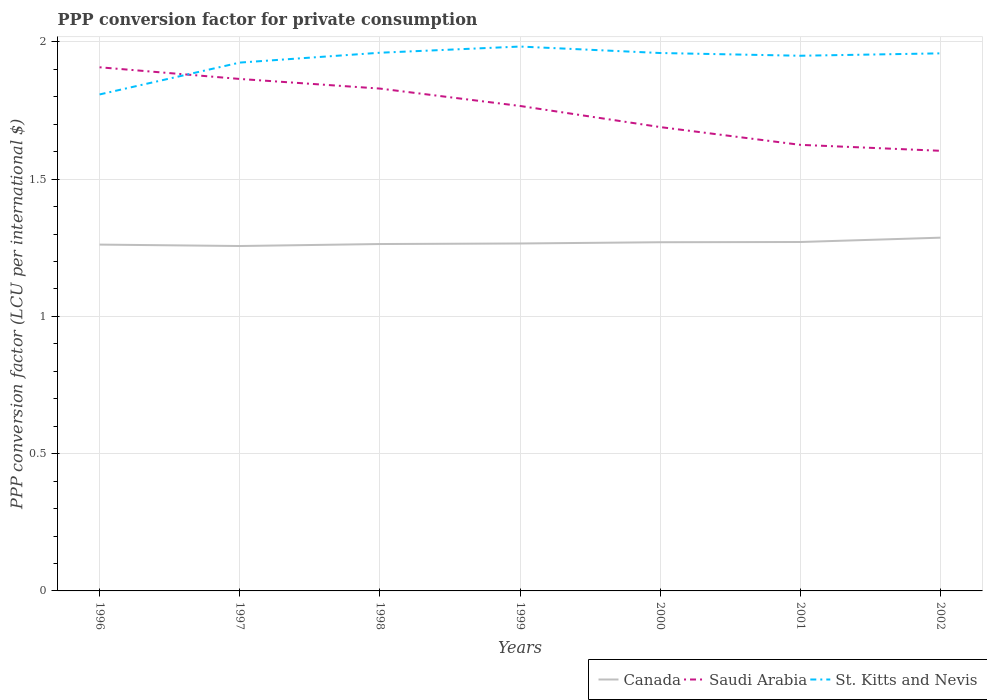How many different coloured lines are there?
Your response must be concise. 3. Does the line corresponding to St. Kitts and Nevis intersect with the line corresponding to Canada?
Keep it short and to the point. No. Across all years, what is the maximum PPP conversion factor for private consumption in Canada?
Your response must be concise. 1.26. What is the total PPP conversion factor for private consumption in Saudi Arabia in the graph?
Provide a succinct answer. 0.3. What is the difference between the highest and the second highest PPP conversion factor for private consumption in St. Kitts and Nevis?
Keep it short and to the point. 0.17. What is the difference between the highest and the lowest PPP conversion factor for private consumption in Saudi Arabia?
Keep it short and to the point. 4. Is the PPP conversion factor for private consumption in St. Kitts and Nevis strictly greater than the PPP conversion factor for private consumption in Saudi Arabia over the years?
Offer a very short reply. No. What is the difference between two consecutive major ticks on the Y-axis?
Your answer should be compact. 0.5. Does the graph contain any zero values?
Offer a very short reply. No. What is the title of the graph?
Keep it short and to the point. PPP conversion factor for private consumption. Does "Korea (Democratic)" appear as one of the legend labels in the graph?
Offer a very short reply. No. What is the label or title of the X-axis?
Provide a succinct answer. Years. What is the label or title of the Y-axis?
Give a very brief answer. PPP conversion factor (LCU per international $). What is the PPP conversion factor (LCU per international $) of Canada in 1996?
Your response must be concise. 1.26. What is the PPP conversion factor (LCU per international $) of Saudi Arabia in 1996?
Your answer should be compact. 1.91. What is the PPP conversion factor (LCU per international $) in St. Kitts and Nevis in 1996?
Provide a succinct answer. 1.81. What is the PPP conversion factor (LCU per international $) of Canada in 1997?
Keep it short and to the point. 1.26. What is the PPP conversion factor (LCU per international $) in Saudi Arabia in 1997?
Your response must be concise. 1.87. What is the PPP conversion factor (LCU per international $) in St. Kitts and Nevis in 1997?
Keep it short and to the point. 1.92. What is the PPP conversion factor (LCU per international $) of Canada in 1998?
Offer a terse response. 1.26. What is the PPP conversion factor (LCU per international $) in Saudi Arabia in 1998?
Your answer should be very brief. 1.83. What is the PPP conversion factor (LCU per international $) in St. Kitts and Nevis in 1998?
Ensure brevity in your answer.  1.96. What is the PPP conversion factor (LCU per international $) in Canada in 1999?
Make the answer very short. 1.27. What is the PPP conversion factor (LCU per international $) of Saudi Arabia in 1999?
Provide a succinct answer. 1.77. What is the PPP conversion factor (LCU per international $) of St. Kitts and Nevis in 1999?
Your answer should be compact. 1.98. What is the PPP conversion factor (LCU per international $) of Canada in 2000?
Offer a terse response. 1.27. What is the PPP conversion factor (LCU per international $) in Saudi Arabia in 2000?
Make the answer very short. 1.69. What is the PPP conversion factor (LCU per international $) of St. Kitts and Nevis in 2000?
Offer a very short reply. 1.96. What is the PPP conversion factor (LCU per international $) in Canada in 2001?
Provide a succinct answer. 1.27. What is the PPP conversion factor (LCU per international $) in Saudi Arabia in 2001?
Keep it short and to the point. 1.63. What is the PPP conversion factor (LCU per international $) of St. Kitts and Nevis in 2001?
Offer a very short reply. 1.95. What is the PPP conversion factor (LCU per international $) in Canada in 2002?
Provide a succinct answer. 1.29. What is the PPP conversion factor (LCU per international $) in Saudi Arabia in 2002?
Provide a short and direct response. 1.6. What is the PPP conversion factor (LCU per international $) of St. Kitts and Nevis in 2002?
Keep it short and to the point. 1.96. Across all years, what is the maximum PPP conversion factor (LCU per international $) of Canada?
Give a very brief answer. 1.29. Across all years, what is the maximum PPP conversion factor (LCU per international $) of Saudi Arabia?
Offer a very short reply. 1.91. Across all years, what is the maximum PPP conversion factor (LCU per international $) of St. Kitts and Nevis?
Ensure brevity in your answer.  1.98. Across all years, what is the minimum PPP conversion factor (LCU per international $) in Canada?
Offer a terse response. 1.26. Across all years, what is the minimum PPP conversion factor (LCU per international $) in Saudi Arabia?
Provide a succinct answer. 1.6. Across all years, what is the minimum PPP conversion factor (LCU per international $) of St. Kitts and Nevis?
Give a very brief answer. 1.81. What is the total PPP conversion factor (LCU per international $) in Canada in the graph?
Provide a short and direct response. 8.88. What is the total PPP conversion factor (LCU per international $) of Saudi Arabia in the graph?
Provide a succinct answer. 12.29. What is the total PPP conversion factor (LCU per international $) in St. Kitts and Nevis in the graph?
Offer a terse response. 13.55. What is the difference between the PPP conversion factor (LCU per international $) in Canada in 1996 and that in 1997?
Offer a very short reply. 0.01. What is the difference between the PPP conversion factor (LCU per international $) in Saudi Arabia in 1996 and that in 1997?
Your answer should be compact. 0.04. What is the difference between the PPP conversion factor (LCU per international $) in St. Kitts and Nevis in 1996 and that in 1997?
Offer a terse response. -0.12. What is the difference between the PPP conversion factor (LCU per international $) in Canada in 1996 and that in 1998?
Provide a succinct answer. -0. What is the difference between the PPP conversion factor (LCU per international $) of Saudi Arabia in 1996 and that in 1998?
Keep it short and to the point. 0.08. What is the difference between the PPP conversion factor (LCU per international $) in St. Kitts and Nevis in 1996 and that in 1998?
Give a very brief answer. -0.15. What is the difference between the PPP conversion factor (LCU per international $) in Canada in 1996 and that in 1999?
Offer a very short reply. -0. What is the difference between the PPP conversion factor (LCU per international $) of Saudi Arabia in 1996 and that in 1999?
Provide a short and direct response. 0.14. What is the difference between the PPP conversion factor (LCU per international $) in St. Kitts and Nevis in 1996 and that in 1999?
Give a very brief answer. -0.17. What is the difference between the PPP conversion factor (LCU per international $) in Canada in 1996 and that in 2000?
Your answer should be compact. -0.01. What is the difference between the PPP conversion factor (LCU per international $) of Saudi Arabia in 1996 and that in 2000?
Make the answer very short. 0.22. What is the difference between the PPP conversion factor (LCU per international $) of St. Kitts and Nevis in 1996 and that in 2000?
Make the answer very short. -0.15. What is the difference between the PPP conversion factor (LCU per international $) in Canada in 1996 and that in 2001?
Provide a succinct answer. -0.01. What is the difference between the PPP conversion factor (LCU per international $) in Saudi Arabia in 1996 and that in 2001?
Offer a very short reply. 0.28. What is the difference between the PPP conversion factor (LCU per international $) in St. Kitts and Nevis in 1996 and that in 2001?
Give a very brief answer. -0.14. What is the difference between the PPP conversion factor (LCU per international $) of Canada in 1996 and that in 2002?
Your answer should be compact. -0.03. What is the difference between the PPP conversion factor (LCU per international $) of Saudi Arabia in 1996 and that in 2002?
Your response must be concise. 0.3. What is the difference between the PPP conversion factor (LCU per international $) in St. Kitts and Nevis in 1996 and that in 2002?
Make the answer very short. -0.15. What is the difference between the PPP conversion factor (LCU per international $) of Canada in 1997 and that in 1998?
Provide a succinct answer. -0.01. What is the difference between the PPP conversion factor (LCU per international $) of Saudi Arabia in 1997 and that in 1998?
Ensure brevity in your answer.  0.04. What is the difference between the PPP conversion factor (LCU per international $) in St. Kitts and Nevis in 1997 and that in 1998?
Your answer should be compact. -0.04. What is the difference between the PPP conversion factor (LCU per international $) of Canada in 1997 and that in 1999?
Ensure brevity in your answer.  -0.01. What is the difference between the PPP conversion factor (LCU per international $) of Saudi Arabia in 1997 and that in 1999?
Make the answer very short. 0.1. What is the difference between the PPP conversion factor (LCU per international $) in St. Kitts and Nevis in 1997 and that in 1999?
Your answer should be compact. -0.06. What is the difference between the PPP conversion factor (LCU per international $) in Canada in 1997 and that in 2000?
Make the answer very short. -0.01. What is the difference between the PPP conversion factor (LCU per international $) in Saudi Arabia in 1997 and that in 2000?
Make the answer very short. 0.18. What is the difference between the PPP conversion factor (LCU per international $) in St. Kitts and Nevis in 1997 and that in 2000?
Keep it short and to the point. -0.03. What is the difference between the PPP conversion factor (LCU per international $) of Canada in 1997 and that in 2001?
Keep it short and to the point. -0.01. What is the difference between the PPP conversion factor (LCU per international $) of Saudi Arabia in 1997 and that in 2001?
Make the answer very short. 0.24. What is the difference between the PPP conversion factor (LCU per international $) in St. Kitts and Nevis in 1997 and that in 2001?
Your answer should be very brief. -0.02. What is the difference between the PPP conversion factor (LCU per international $) of Canada in 1997 and that in 2002?
Your response must be concise. -0.03. What is the difference between the PPP conversion factor (LCU per international $) in Saudi Arabia in 1997 and that in 2002?
Give a very brief answer. 0.26. What is the difference between the PPP conversion factor (LCU per international $) in St. Kitts and Nevis in 1997 and that in 2002?
Your response must be concise. -0.03. What is the difference between the PPP conversion factor (LCU per international $) of Canada in 1998 and that in 1999?
Provide a short and direct response. -0. What is the difference between the PPP conversion factor (LCU per international $) of Saudi Arabia in 1998 and that in 1999?
Provide a short and direct response. 0.06. What is the difference between the PPP conversion factor (LCU per international $) in St. Kitts and Nevis in 1998 and that in 1999?
Your response must be concise. -0.02. What is the difference between the PPP conversion factor (LCU per international $) of Canada in 1998 and that in 2000?
Offer a terse response. -0.01. What is the difference between the PPP conversion factor (LCU per international $) in Saudi Arabia in 1998 and that in 2000?
Keep it short and to the point. 0.14. What is the difference between the PPP conversion factor (LCU per international $) of St. Kitts and Nevis in 1998 and that in 2000?
Provide a short and direct response. 0. What is the difference between the PPP conversion factor (LCU per international $) in Canada in 1998 and that in 2001?
Offer a very short reply. -0.01. What is the difference between the PPP conversion factor (LCU per international $) in Saudi Arabia in 1998 and that in 2001?
Give a very brief answer. 0.2. What is the difference between the PPP conversion factor (LCU per international $) of St. Kitts and Nevis in 1998 and that in 2001?
Give a very brief answer. 0.01. What is the difference between the PPP conversion factor (LCU per international $) of Canada in 1998 and that in 2002?
Make the answer very short. -0.02. What is the difference between the PPP conversion factor (LCU per international $) in Saudi Arabia in 1998 and that in 2002?
Provide a short and direct response. 0.23. What is the difference between the PPP conversion factor (LCU per international $) in St. Kitts and Nevis in 1998 and that in 2002?
Your answer should be very brief. 0. What is the difference between the PPP conversion factor (LCU per international $) in Canada in 1999 and that in 2000?
Ensure brevity in your answer.  -0. What is the difference between the PPP conversion factor (LCU per international $) in Saudi Arabia in 1999 and that in 2000?
Your response must be concise. 0.08. What is the difference between the PPP conversion factor (LCU per international $) of St. Kitts and Nevis in 1999 and that in 2000?
Keep it short and to the point. 0.02. What is the difference between the PPP conversion factor (LCU per international $) in Canada in 1999 and that in 2001?
Make the answer very short. -0.01. What is the difference between the PPP conversion factor (LCU per international $) of Saudi Arabia in 1999 and that in 2001?
Your answer should be very brief. 0.14. What is the difference between the PPP conversion factor (LCU per international $) in St. Kitts and Nevis in 1999 and that in 2001?
Offer a very short reply. 0.03. What is the difference between the PPP conversion factor (LCU per international $) in Canada in 1999 and that in 2002?
Provide a short and direct response. -0.02. What is the difference between the PPP conversion factor (LCU per international $) in Saudi Arabia in 1999 and that in 2002?
Keep it short and to the point. 0.16. What is the difference between the PPP conversion factor (LCU per international $) in St. Kitts and Nevis in 1999 and that in 2002?
Make the answer very short. 0.02. What is the difference between the PPP conversion factor (LCU per international $) in Canada in 2000 and that in 2001?
Ensure brevity in your answer.  -0. What is the difference between the PPP conversion factor (LCU per international $) of Saudi Arabia in 2000 and that in 2001?
Provide a short and direct response. 0.06. What is the difference between the PPP conversion factor (LCU per international $) of Canada in 2000 and that in 2002?
Ensure brevity in your answer.  -0.02. What is the difference between the PPP conversion factor (LCU per international $) of Saudi Arabia in 2000 and that in 2002?
Offer a very short reply. 0.09. What is the difference between the PPP conversion factor (LCU per international $) in St. Kitts and Nevis in 2000 and that in 2002?
Give a very brief answer. 0. What is the difference between the PPP conversion factor (LCU per international $) of Canada in 2001 and that in 2002?
Offer a very short reply. -0.02. What is the difference between the PPP conversion factor (LCU per international $) in Saudi Arabia in 2001 and that in 2002?
Give a very brief answer. 0.02. What is the difference between the PPP conversion factor (LCU per international $) of St. Kitts and Nevis in 2001 and that in 2002?
Offer a terse response. -0.01. What is the difference between the PPP conversion factor (LCU per international $) in Canada in 1996 and the PPP conversion factor (LCU per international $) in Saudi Arabia in 1997?
Provide a succinct answer. -0.6. What is the difference between the PPP conversion factor (LCU per international $) in Canada in 1996 and the PPP conversion factor (LCU per international $) in St. Kitts and Nevis in 1997?
Give a very brief answer. -0.66. What is the difference between the PPP conversion factor (LCU per international $) in Saudi Arabia in 1996 and the PPP conversion factor (LCU per international $) in St. Kitts and Nevis in 1997?
Your answer should be very brief. -0.02. What is the difference between the PPP conversion factor (LCU per international $) of Canada in 1996 and the PPP conversion factor (LCU per international $) of Saudi Arabia in 1998?
Offer a terse response. -0.57. What is the difference between the PPP conversion factor (LCU per international $) of Canada in 1996 and the PPP conversion factor (LCU per international $) of St. Kitts and Nevis in 1998?
Your answer should be compact. -0.7. What is the difference between the PPP conversion factor (LCU per international $) in Saudi Arabia in 1996 and the PPP conversion factor (LCU per international $) in St. Kitts and Nevis in 1998?
Your response must be concise. -0.05. What is the difference between the PPP conversion factor (LCU per international $) of Canada in 1996 and the PPP conversion factor (LCU per international $) of Saudi Arabia in 1999?
Keep it short and to the point. -0.51. What is the difference between the PPP conversion factor (LCU per international $) of Canada in 1996 and the PPP conversion factor (LCU per international $) of St. Kitts and Nevis in 1999?
Ensure brevity in your answer.  -0.72. What is the difference between the PPP conversion factor (LCU per international $) of Saudi Arabia in 1996 and the PPP conversion factor (LCU per international $) of St. Kitts and Nevis in 1999?
Give a very brief answer. -0.08. What is the difference between the PPP conversion factor (LCU per international $) of Canada in 1996 and the PPP conversion factor (LCU per international $) of Saudi Arabia in 2000?
Your response must be concise. -0.43. What is the difference between the PPP conversion factor (LCU per international $) in Canada in 1996 and the PPP conversion factor (LCU per international $) in St. Kitts and Nevis in 2000?
Make the answer very short. -0.7. What is the difference between the PPP conversion factor (LCU per international $) in Saudi Arabia in 1996 and the PPP conversion factor (LCU per international $) in St. Kitts and Nevis in 2000?
Give a very brief answer. -0.05. What is the difference between the PPP conversion factor (LCU per international $) in Canada in 1996 and the PPP conversion factor (LCU per international $) in Saudi Arabia in 2001?
Offer a very short reply. -0.36. What is the difference between the PPP conversion factor (LCU per international $) of Canada in 1996 and the PPP conversion factor (LCU per international $) of St. Kitts and Nevis in 2001?
Your answer should be compact. -0.69. What is the difference between the PPP conversion factor (LCU per international $) in Saudi Arabia in 1996 and the PPP conversion factor (LCU per international $) in St. Kitts and Nevis in 2001?
Provide a succinct answer. -0.04. What is the difference between the PPP conversion factor (LCU per international $) of Canada in 1996 and the PPP conversion factor (LCU per international $) of Saudi Arabia in 2002?
Your answer should be compact. -0.34. What is the difference between the PPP conversion factor (LCU per international $) of Canada in 1996 and the PPP conversion factor (LCU per international $) of St. Kitts and Nevis in 2002?
Your answer should be very brief. -0.7. What is the difference between the PPP conversion factor (LCU per international $) in Saudi Arabia in 1996 and the PPP conversion factor (LCU per international $) in St. Kitts and Nevis in 2002?
Offer a very short reply. -0.05. What is the difference between the PPP conversion factor (LCU per international $) in Canada in 1997 and the PPP conversion factor (LCU per international $) in Saudi Arabia in 1998?
Provide a succinct answer. -0.57. What is the difference between the PPP conversion factor (LCU per international $) in Canada in 1997 and the PPP conversion factor (LCU per international $) in St. Kitts and Nevis in 1998?
Your answer should be very brief. -0.7. What is the difference between the PPP conversion factor (LCU per international $) in Saudi Arabia in 1997 and the PPP conversion factor (LCU per international $) in St. Kitts and Nevis in 1998?
Your answer should be very brief. -0.1. What is the difference between the PPP conversion factor (LCU per international $) of Canada in 1997 and the PPP conversion factor (LCU per international $) of Saudi Arabia in 1999?
Your answer should be compact. -0.51. What is the difference between the PPP conversion factor (LCU per international $) in Canada in 1997 and the PPP conversion factor (LCU per international $) in St. Kitts and Nevis in 1999?
Ensure brevity in your answer.  -0.73. What is the difference between the PPP conversion factor (LCU per international $) of Saudi Arabia in 1997 and the PPP conversion factor (LCU per international $) of St. Kitts and Nevis in 1999?
Make the answer very short. -0.12. What is the difference between the PPP conversion factor (LCU per international $) in Canada in 1997 and the PPP conversion factor (LCU per international $) in Saudi Arabia in 2000?
Ensure brevity in your answer.  -0.43. What is the difference between the PPP conversion factor (LCU per international $) in Canada in 1997 and the PPP conversion factor (LCU per international $) in St. Kitts and Nevis in 2000?
Your answer should be very brief. -0.7. What is the difference between the PPP conversion factor (LCU per international $) of Saudi Arabia in 1997 and the PPP conversion factor (LCU per international $) of St. Kitts and Nevis in 2000?
Your response must be concise. -0.09. What is the difference between the PPP conversion factor (LCU per international $) of Canada in 1997 and the PPP conversion factor (LCU per international $) of Saudi Arabia in 2001?
Keep it short and to the point. -0.37. What is the difference between the PPP conversion factor (LCU per international $) in Canada in 1997 and the PPP conversion factor (LCU per international $) in St. Kitts and Nevis in 2001?
Keep it short and to the point. -0.69. What is the difference between the PPP conversion factor (LCU per international $) of Saudi Arabia in 1997 and the PPP conversion factor (LCU per international $) of St. Kitts and Nevis in 2001?
Your answer should be compact. -0.08. What is the difference between the PPP conversion factor (LCU per international $) in Canada in 1997 and the PPP conversion factor (LCU per international $) in Saudi Arabia in 2002?
Provide a succinct answer. -0.35. What is the difference between the PPP conversion factor (LCU per international $) in Canada in 1997 and the PPP conversion factor (LCU per international $) in St. Kitts and Nevis in 2002?
Offer a terse response. -0.7. What is the difference between the PPP conversion factor (LCU per international $) of Saudi Arabia in 1997 and the PPP conversion factor (LCU per international $) of St. Kitts and Nevis in 2002?
Make the answer very short. -0.09. What is the difference between the PPP conversion factor (LCU per international $) of Canada in 1998 and the PPP conversion factor (LCU per international $) of Saudi Arabia in 1999?
Provide a succinct answer. -0.5. What is the difference between the PPP conversion factor (LCU per international $) in Canada in 1998 and the PPP conversion factor (LCU per international $) in St. Kitts and Nevis in 1999?
Your answer should be very brief. -0.72. What is the difference between the PPP conversion factor (LCU per international $) in Saudi Arabia in 1998 and the PPP conversion factor (LCU per international $) in St. Kitts and Nevis in 1999?
Ensure brevity in your answer.  -0.15. What is the difference between the PPP conversion factor (LCU per international $) in Canada in 1998 and the PPP conversion factor (LCU per international $) in Saudi Arabia in 2000?
Provide a short and direct response. -0.43. What is the difference between the PPP conversion factor (LCU per international $) of Canada in 1998 and the PPP conversion factor (LCU per international $) of St. Kitts and Nevis in 2000?
Make the answer very short. -0.7. What is the difference between the PPP conversion factor (LCU per international $) in Saudi Arabia in 1998 and the PPP conversion factor (LCU per international $) in St. Kitts and Nevis in 2000?
Provide a succinct answer. -0.13. What is the difference between the PPP conversion factor (LCU per international $) of Canada in 1998 and the PPP conversion factor (LCU per international $) of Saudi Arabia in 2001?
Ensure brevity in your answer.  -0.36. What is the difference between the PPP conversion factor (LCU per international $) of Canada in 1998 and the PPP conversion factor (LCU per international $) of St. Kitts and Nevis in 2001?
Give a very brief answer. -0.69. What is the difference between the PPP conversion factor (LCU per international $) of Saudi Arabia in 1998 and the PPP conversion factor (LCU per international $) of St. Kitts and Nevis in 2001?
Provide a succinct answer. -0.12. What is the difference between the PPP conversion factor (LCU per international $) of Canada in 1998 and the PPP conversion factor (LCU per international $) of Saudi Arabia in 2002?
Make the answer very short. -0.34. What is the difference between the PPP conversion factor (LCU per international $) of Canada in 1998 and the PPP conversion factor (LCU per international $) of St. Kitts and Nevis in 2002?
Offer a terse response. -0.69. What is the difference between the PPP conversion factor (LCU per international $) of Saudi Arabia in 1998 and the PPP conversion factor (LCU per international $) of St. Kitts and Nevis in 2002?
Your answer should be very brief. -0.13. What is the difference between the PPP conversion factor (LCU per international $) of Canada in 1999 and the PPP conversion factor (LCU per international $) of Saudi Arabia in 2000?
Give a very brief answer. -0.42. What is the difference between the PPP conversion factor (LCU per international $) in Canada in 1999 and the PPP conversion factor (LCU per international $) in St. Kitts and Nevis in 2000?
Provide a succinct answer. -0.69. What is the difference between the PPP conversion factor (LCU per international $) in Saudi Arabia in 1999 and the PPP conversion factor (LCU per international $) in St. Kitts and Nevis in 2000?
Your answer should be compact. -0.19. What is the difference between the PPP conversion factor (LCU per international $) in Canada in 1999 and the PPP conversion factor (LCU per international $) in Saudi Arabia in 2001?
Give a very brief answer. -0.36. What is the difference between the PPP conversion factor (LCU per international $) of Canada in 1999 and the PPP conversion factor (LCU per international $) of St. Kitts and Nevis in 2001?
Offer a terse response. -0.68. What is the difference between the PPP conversion factor (LCU per international $) of Saudi Arabia in 1999 and the PPP conversion factor (LCU per international $) of St. Kitts and Nevis in 2001?
Ensure brevity in your answer.  -0.18. What is the difference between the PPP conversion factor (LCU per international $) in Canada in 1999 and the PPP conversion factor (LCU per international $) in Saudi Arabia in 2002?
Ensure brevity in your answer.  -0.34. What is the difference between the PPP conversion factor (LCU per international $) in Canada in 1999 and the PPP conversion factor (LCU per international $) in St. Kitts and Nevis in 2002?
Your answer should be very brief. -0.69. What is the difference between the PPP conversion factor (LCU per international $) in Saudi Arabia in 1999 and the PPP conversion factor (LCU per international $) in St. Kitts and Nevis in 2002?
Your answer should be very brief. -0.19. What is the difference between the PPP conversion factor (LCU per international $) of Canada in 2000 and the PPP conversion factor (LCU per international $) of Saudi Arabia in 2001?
Make the answer very short. -0.35. What is the difference between the PPP conversion factor (LCU per international $) in Canada in 2000 and the PPP conversion factor (LCU per international $) in St. Kitts and Nevis in 2001?
Your answer should be compact. -0.68. What is the difference between the PPP conversion factor (LCU per international $) of Saudi Arabia in 2000 and the PPP conversion factor (LCU per international $) of St. Kitts and Nevis in 2001?
Offer a very short reply. -0.26. What is the difference between the PPP conversion factor (LCU per international $) in Canada in 2000 and the PPP conversion factor (LCU per international $) in Saudi Arabia in 2002?
Offer a very short reply. -0.33. What is the difference between the PPP conversion factor (LCU per international $) in Canada in 2000 and the PPP conversion factor (LCU per international $) in St. Kitts and Nevis in 2002?
Ensure brevity in your answer.  -0.69. What is the difference between the PPP conversion factor (LCU per international $) of Saudi Arabia in 2000 and the PPP conversion factor (LCU per international $) of St. Kitts and Nevis in 2002?
Ensure brevity in your answer.  -0.27. What is the difference between the PPP conversion factor (LCU per international $) in Canada in 2001 and the PPP conversion factor (LCU per international $) in Saudi Arabia in 2002?
Provide a short and direct response. -0.33. What is the difference between the PPP conversion factor (LCU per international $) of Canada in 2001 and the PPP conversion factor (LCU per international $) of St. Kitts and Nevis in 2002?
Your answer should be compact. -0.69. What is the difference between the PPP conversion factor (LCU per international $) of Saudi Arabia in 2001 and the PPP conversion factor (LCU per international $) of St. Kitts and Nevis in 2002?
Make the answer very short. -0.33. What is the average PPP conversion factor (LCU per international $) in Canada per year?
Provide a short and direct response. 1.27. What is the average PPP conversion factor (LCU per international $) of Saudi Arabia per year?
Your response must be concise. 1.76. What is the average PPP conversion factor (LCU per international $) in St. Kitts and Nevis per year?
Ensure brevity in your answer.  1.94. In the year 1996, what is the difference between the PPP conversion factor (LCU per international $) in Canada and PPP conversion factor (LCU per international $) in Saudi Arabia?
Give a very brief answer. -0.65. In the year 1996, what is the difference between the PPP conversion factor (LCU per international $) in Canada and PPP conversion factor (LCU per international $) in St. Kitts and Nevis?
Ensure brevity in your answer.  -0.55. In the year 1996, what is the difference between the PPP conversion factor (LCU per international $) in Saudi Arabia and PPP conversion factor (LCU per international $) in St. Kitts and Nevis?
Your answer should be very brief. 0.1. In the year 1997, what is the difference between the PPP conversion factor (LCU per international $) of Canada and PPP conversion factor (LCU per international $) of Saudi Arabia?
Ensure brevity in your answer.  -0.61. In the year 1997, what is the difference between the PPP conversion factor (LCU per international $) in Canada and PPP conversion factor (LCU per international $) in St. Kitts and Nevis?
Offer a very short reply. -0.67. In the year 1997, what is the difference between the PPP conversion factor (LCU per international $) of Saudi Arabia and PPP conversion factor (LCU per international $) of St. Kitts and Nevis?
Offer a very short reply. -0.06. In the year 1998, what is the difference between the PPP conversion factor (LCU per international $) in Canada and PPP conversion factor (LCU per international $) in Saudi Arabia?
Keep it short and to the point. -0.57. In the year 1998, what is the difference between the PPP conversion factor (LCU per international $) in Canada and PPP conversion factor (LCU per international $) in St. Kitts and Nevis?
Your answer should be very brief. -0.7. In the year 1998, what is the difference between the PPP conversion factor (LCU per international $) in Saudi Arabia and PPP conversion factor (LCU per international $) in St. Kitts and Nevis?
Keep it short and to the point. -0.13. In the year 1999, what is the difference between the PPP conversion factor (LCU per international $) in Canada and PPP conversion factor (LCU per international $) in Saudi Arabia?
Your response must be concise. -0.5. In the year 1999, what is the difference between the PPP conversion factor (LCU per international $) of Canada and PPP conversion factor (LCU per international $) of St. Kitts and Nevis?
Make the answer very short. -0.72. In the year 1999, what is the difference between the PPP conversion factor (LCU per international $) of Saudi Arabia and PPP conversion factor (LCU per international $) of St. Kitts and Nevis?
Your answer should be compact. -0.22. In the year 2000, what is the difference between the PPP conversion factor (LCU per international $) in Canada and PPP conversion factor (LCU per international $) in Saudi Arabia?
Offer a terse response. -0.42. In the year 2000, what is the difference between the PPP conversion factor (LCU per international $) of Canada and PPP conversion factor (LCU per international $) of St. Kitts and Nevis?
Offer a very short reply. -0.69. In the year 2000, what is the difference between the PPP conversion factor (LCU per international $) of Saudi Arabia and PPP conversion factor (LCU per international $) of St. Kitts and Nevis?
Make the answer very short. -0.27. In the year 2001, what is the difference between the PPP conversion factor (LCU per international $) of Canada and PPP conversion factor (LCU per international $) of Saudi Arabia?
Ensure brevity in your answer.  -0.35. In the year 2001, what is the difference between the PPP conversion factor (LCU per international $) of Canada and PPP conversion factor (LCU per international $) of St. Kitts and Nevis?
Provide a short and direct response. -0.68. In the year 2001, what is the difference between the PPP conversion factor (LCU per international $) in Saudi Arabia and PPP conversion factor (LCU per international $) in St. Kitts and Nevis?
Your response must be concise. -0.32. In the year 2002, what is the difference between the PPP conversion factor (LCU per international $) of Canada and PPP conversion factor (LCU per international $) of Saudi Arabia?
Your response must be concise. -0.32. In the year 2002, what is the difference between the PPP conversion factor (LCU per international $) in Canada and PPP conversion factor (LCU per international $) in St. Kitts and Nevis?
Keep it short and to the point. -0.67. In the year 2002, what is the difference between the PPP conversion factor (LCU per international $) in Saudi Arabia and PPP conversion factor (LCU per international $) in St. Kitts and Nevis?
Provide a short and direct response. -0.35. What is the ratio of the PPP conversion factor (LCU per international $) in Canada in 1996 to that in 1997?
Your response must be concise. 1. What is the ratio of the PPP conversion factor (LCU per international $) in Saudi Arabia in 1996 to that in 1997?
Give a very brief answer. 1.02. What is the ratio of the PPP conversion factor (LCU per international $) of St. Kitts and Nevis in 1996 to that in 1997?
Provide a succinct answer. 0.94. What is the ratio of the PPP conversion factor (LCU per international $) in Saudi Arabia in 1996 to that in 1998?
Provide a short and direct response. 1.04. What is the ratio of the PPP conversion factor (LCU per international $) in St. Kitts and Nevis in 1996 to that in 1998?
Provide a succinct answer. 0.92. What is the ratio of the PPP conversion factor (LCU per international $) of Saudi Arabia in 1996 to that in 1999?
Ensure brevity in your answer.  1.08. What is the ratio of the PPP conversion factor (LCU per international $) of St. Kitts and Nevis in 1996 to that in 1999?
Keep it short and to the point. 0.91. What is the ratio of the PPP conversion factor (LCU per international $) of Canada in 1996 to that in 2000?
Make the answer very short. 0.99. What is the ratio of the PPP conversion factor (LCU per international $) in Saudi Arabia in 1996 to that in 2000?
Offer a terse response. 1.13. What is the ratio of the PPP conversion factor (LCU per international $) of St. Kitts and Nevis in 1996 to that in 2000?
Provide a short and direct response. 0.92. What is the ratio of the PPP conversion factor (LCU per international $) of Saudi Arabia in 1996 to that in 2001?
Provide a succinct answer. 1.17. What is the ratio of the PPP conversion factor (LCU per international $) of St. Kitts and Nevis in 1996 to that in 2001?
Provide a short and direct response. 0.93. What is the ratio of the PPP conversion factor (LCU per international $) in Canada in 1996 to that in 2002?
Make the answer very short. 0.98. What is the ratio of the PPP conversion factor (LCU per international $) of Saudi Arabia in 1996 to that in 2002?
Your answer should be very brief. 1.19. What is the ratio of the PPP conversion factor (LCU per international $) of St. Kitts and Nevis in 1996 to that in 2002?
Your answer should be compact. 0.92. What is the ratio of the PPP conversion factor (LCU per international $) in Saudi Arabia in 1997 to that in 1998?
Your response must be concise. 1.02. What is the ratio of the PPP conversion factor (LCU per international $) of St. Kitts and Nevis in 1997 to that in 1998?
Your response must be concise. 0.98. What is the ratio of the PPP conversion factor (LCU per international $) of Saudi Arabia in 1997 to that in 1999?
Ensure brevity in your answer.  1.06. What is the ratio of the PPP conversion factor (LCU per international $) in St. Kitts and Nevis in 1997 to that in 1999?
Your answer should be very brief. 0.97. What is the ratio of the PPP conversion factor (LCU per international $) of Saudi Arabia in 1997 to that in 2000?
Offer a terse response. 1.1. What is the ratio of the PPP conversion factor (LCU per international $) in St. Kitts and Nevis in 1997 to that in 2000?
Offer a very short reply. 0.98. What is the ratio of the PPP conversion factor (LCU per international $) of Saudi Arabia in 1997 to that in 2001?
Give a very brief answer. 1.15. What is the ratio of the PPP conversion factor (LCU per international $) of St. Kitts and Nevis in 1997 to that in 2001?
Ensure brevity in your answer.  0.99. What is the ratio of the PPP conversion factor (LCU per international $) of Canada in 1997 to that in 2002?
Keep it short and to the point. 0.98. What is the ratio of the PPP conversion factor (LCU per international $) in Saudi Arabia in 1997 to that in 2002?
Your answer should be very brief. 1.16. What is the ratio of the PPP conversion factor (LCU per international $) of St. Kitts and Nevis in 1997 to that in 2002?
Make the answer very short. 0.98. What is the ratio of the PPP conversion factor (LCU per international $) in Saudi Arabia in 1998 to that in 1999?
Offer a terse response. 1.04. What is the ratio of the PPP conversion factor (LCU per international $) in Canada in 1998 to that in 2000?
Ensure brevity in your answer.  0.99. What is the ratio of the PPP conversion factor (LCU per international $) of Saudi Arabia in 1998 to that in 2000?
Offer a very short reply. 1.08. What is the ratio of the PPP conversion factor (LCU per international $) of Saudi Arabia in 1998 to that in 2001?
Make the answer very short. 1.13. What is the ratio of the PPP conversion factor (LCU per international $) of St. Kitts and Nevis in 1998 to that in 2001?
Offer a very short reply. 1.01. What is the ratio of the PPP conversion factor (LCU per international $) in Saudi Arabia in 1998 to that in 2002?
Offer a terse response. 1.14. What is the ratio of the PPP conversion factor (LCU per international $) in Saudi Arabia in 1999 to that in 2000?
Make the answer very short. 1.05. What is the ratio of the PPP conversion factor (LCU per international $) of St. Kitts and Nevis in 1999 to that in 2000?
Ensure brevity in your answer.  1.01. What is the ratio of the PPP conversion factor (LCU per international $) of Canada in 1999 to that in 2001?
Your answer should be compact. 1. What is the ratio of the PPP conversion factor (LCU per international $) in Saudi Arabia in 1999 to that in 2001?
Offer a terse response. 1.09. What is the ratio of the PPP conversion factor (LCU per international $) of St. Kitts and Nevis in 1999 to that in 2001?
Provide a short and direct response. 1.02. What is the ratio of the PPP conversion factor (LCU per international $) in Canada in 1999 to that in 2002?
Give a very brief answer. 0.98. What is the ratio of the PPP conversion factor (LCU per international $) in Saudi Arabia in 1999 to that in 2002?
Offer a terse response. 1.1. What is the ratio of the PPP conversion factor (LCU per international $) of St. Kitts and Nevis in 1999 to that in 2002?
Give a very brief answer. 1.01. What is the ratio of the PPP conversion factor (LCU per international $) of Canada in 2000 to that in 2001?
Ensure brevity in your answer.  1. What is the ratio of the PPP conversion factor (LCU per international $) of Saudi Arabia in 2000 to that in 2001?
Give a very brief answer. 1.04. What is the ratio of the PPP conversion factor (LCU per international $) of St. Kitts and Nevis in 2000 to that in 2001?
Give a very brief answer. 1.01. What is the ratio of the PPP conversion factor (LCU per international $) in Canada in 2000 to that in 2002?
Give a very brief answer. 0.99. What is the ratio of the PPP conversion factor (LCU per international $) of Saudi Arabia in 2000 to that in 2002?
Your answer should be compact. 1.05. What is the ratio of the PPP conversion factor (LCU per international $) of Saudi Arabia in 2001 to that in 2002?
Make the answer very short. 1.01. What is the ratio of the PPP conversion factor (LCU per international $) of St. Kitts and Nevis in 2001 to that in 2002?
Keep it short and to the point. 1. What is the difference between the highest and the second highest PPP conversion factor (LCU per international $) of Canada?
Provide a short and direct response. 0.02. What is the difference between the highest and the second highest PPP conversion factor (LCU per international $) of Saudi Arabia?
Provide a short and direct response. 0.04. What is the difference between the highest and the second highest PPP conversion factor (LCU per international $) of St. Kitts and Nevis?
Offer a very short reply. 0.02. What is the difference between the highest and the lowest PPP conversion factor (LCU per international $) of Canada?
Provide a short and direct response. 0.03. What is the difference between the highest and the lowest PPP conversion factor (LCU per international $) of Saudi Arabia?
Your response must be concise. 0.3. What is the difference between the highest and the lowest PPP conversion factor (LCU per international $) in St. Kitts and Nevis?
Make the answer very short. 0.17. 